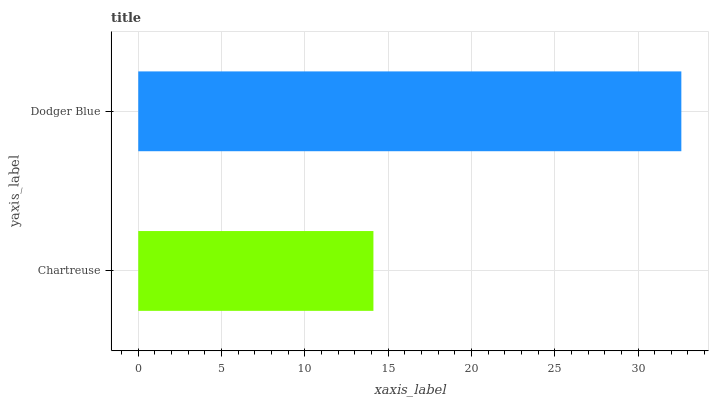Is Chartreuse the minimum?
Answer yes or no. Yes. Is Dodger Blue the maximum?
Answer yes or no. Yes. Is Dodger Blue the minimum?
Answer yes or no. No. Is Dodger Blue greater than Chartreuse?
Answer yes or no. Yes. Is Chartreuse less than Dodger Blue?
Answer yes or no. Yes. Is Chartreuse greater than Dodger Blue?
Answer yes or no. No. Is Dodger Blue less than Chartreuse?
Answer yes or no. No. Is Dodger Blue the high median?
Answer yes or no. Yes. Is Chartreuse the low median?
Answer yes or no. Yes. Is Chartreuse the high median?
Answer yes or no. No. Is Dodger Blue the low median?
Answer yes or no. No. 